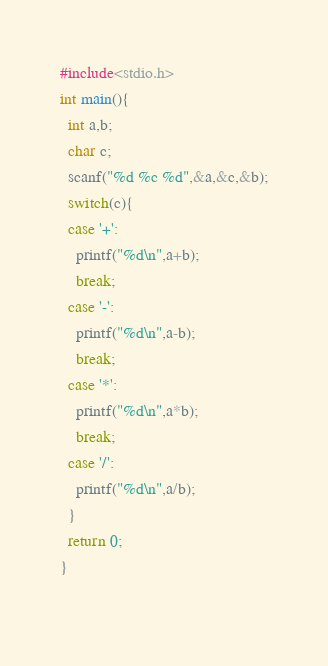<code> <loc_0><loc_0><loc_500><loc_500><_C_>#include<stdio.h>
int main(){
  int a,b;
  char c;
  scanf("%d %c %d",&a,&c,&b);
  switch(c){
  case '+':
    printf("%d\n",a+b);
    break;
  case '-':
    printf("%d\n",a-b);
    break;
  case '*':
    printf("%d\n",a*b);
    break;
  case '/':
    printf("%d\n",a/b);
  }
  return 0;
}
  </code> 